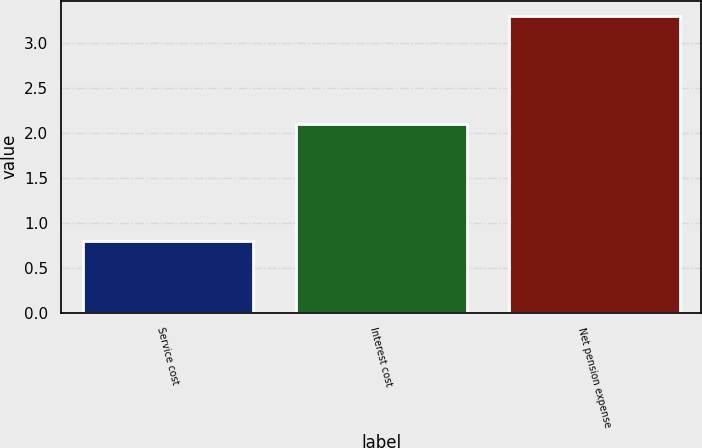Convert chart to OTSL. <chart><loc_0><loc_0><loc_500><loc_500><bar_chart><fcel>Service cost<fcel>Interest cost<fcel>Net pension expense<nl><fcel>0.8<fcel>2.1<fcel>3.3<nl></chart> 